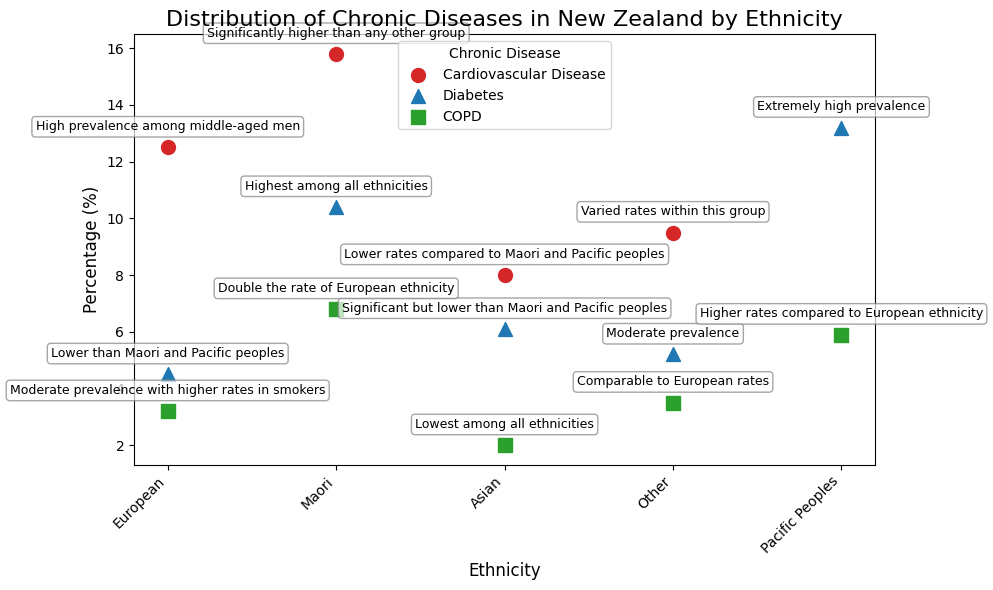Which ethnicity has the highest prevalence of cardiovascular disease? By observing the scatter plot, the point highest on the y-axis for cardiovascular disease (marked in red) corresponds to the Maori ethnicity.
Answer: Maori Which ethnicity has the lowest percentage of COPD? The scatter plot shows the lowest point for COPD (marked in green) on the y-axis for the Asian ethnicity.
Answer: Asian What is the difference in diabetes prevalence between the Maori and European ethnicities? From the scatter plot, identify the points representing diabetes (marked in blue) for both Maori and European ethnicities and calculate the difference: Maori (10.4%) - European (4.5%) = 5.9%.
Answer: 5.9% Which ethnicities show a higher prevalence of COPD than the European ethnicity? Compare the COPD percentages for all ethnicities: European (3.2%), Maori (6.8%), Pacific Peoples (5.9%), Asian (2.0%), and Other (3.5%). The ethnicities with percentages higher than 3.2% are Maori, Pacific Peoples, and Other.
Answer: Maori, Pacific Peoples, Other What is the average percentage of diabetes across all ethnicities? Calculate the average by summing the diabetes percentages for all ethnicities and dividing by the number of ethnicities: (4.5%+10.4%+13.2%+6.1%+5.2%) / 5 = 7.88%.
Answer: 7.88% How does the prevalence of cardiovascular disease among European ethnicity compare to the Other ethnicity group? Check the points for cardiovascular disease for European (12.5%) and Other (9.5%) on the scatter plot. The European percentage is higher than the Other group by 3%.
Answer: European has 3% higher What is the sum of COPD percentages for Maori and Pacific Peoples? From the scatter plot, identify the percentages for COPD in Maori (6.8%) and Pacific Peoples (5.9%) and then sum them up: 6.8% + 5.9% = 12.7%.
Answer: 12.7% Which ethnicity has the greatest disparity in diabetes prevalence compared to the average diabetes prevalence? Calculate the average prevalence as 7.88% and compare the individual percentages: European (4.5%), Maori (10.4%), Pacific Peoples (13.2%), Asian (6.1%), Other (5.2%). The greatest disparity is for Pacific Peoples, at 13.2%, which is 5.32% above the average.
Answer: Pacific Peoples 